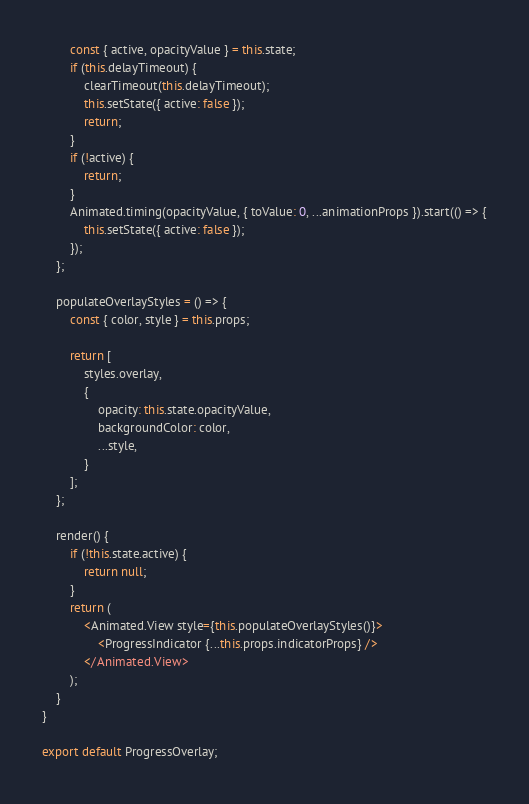Convert code to text. <code><loc_0><loc_0><loc_500><loc_500><_JavaScript_>		const { active, opacityValue } = this.state;
		if (this.delayTimeout) {
			clearTimeout(this.delayTimeout);
			this.setState({ active: false });
			return;
		}
		if (!active) {
			return;
		}
		Animated.timing(opacityValue, { toValue: 0, ...animationProps }).start(() => {
			this.setState({ active: false });
		});
	};

	populateOverlayStyles = () => {
		const { color, style } = this.props;

		return [
			styles.overlay,
			{
				opacity: this.state.opacityValue,
				backgroundColor: color,
				...style,
			}
		];
	};

	render() {
		if (!this.state.active) {
			return null;
		}
		return (
			<Animated.View style={this.populateOverlayStyles()}>
				<ProgressIndicator {...this.props.indicatorProps} />
			</Animated.View>
		);
	}
}

export default ProgressOverlay;
</code> 